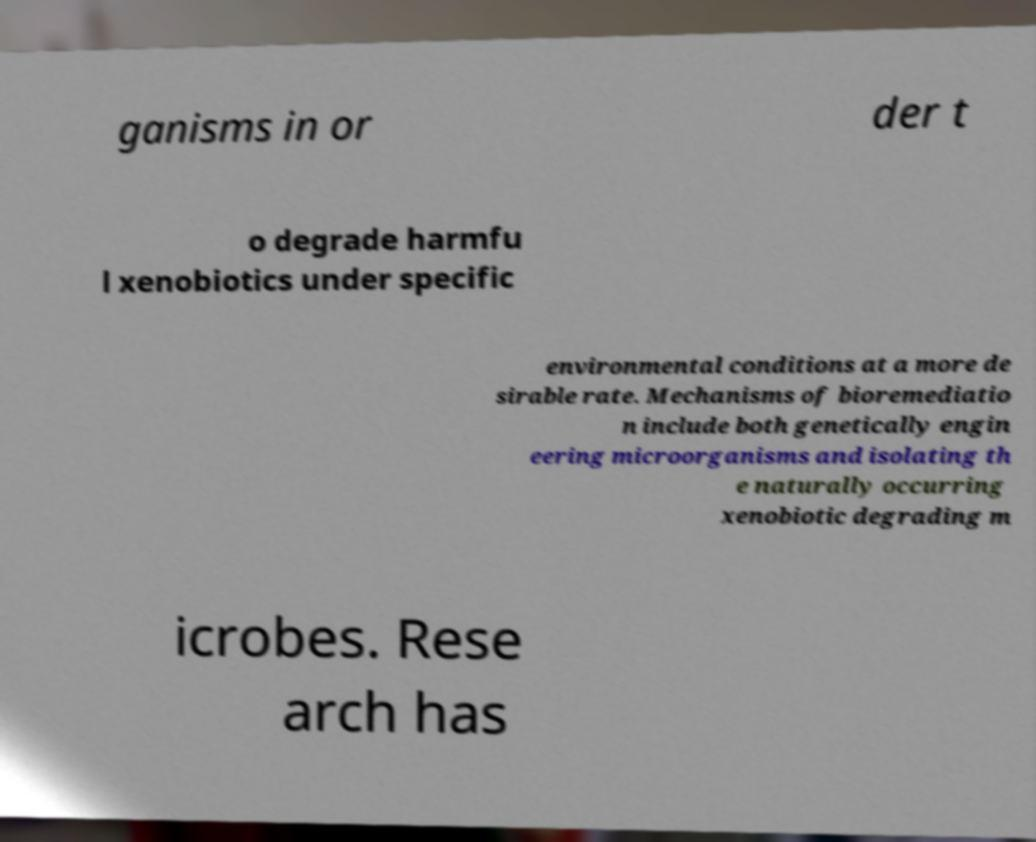Can you read and provide the text displayed in the image?This photo seems to have some interesting text. Can you extract and type it out for me? ganisms in or der t o degrade harmfu l xenobiotics under specific environmental conditions at a more de sirable rate. Mechanisms of bioremediatio n include both genetically engin eering microorganisms and isolating th e naturally occurring xenobiotic degrading m icrobes. Rese arch has 